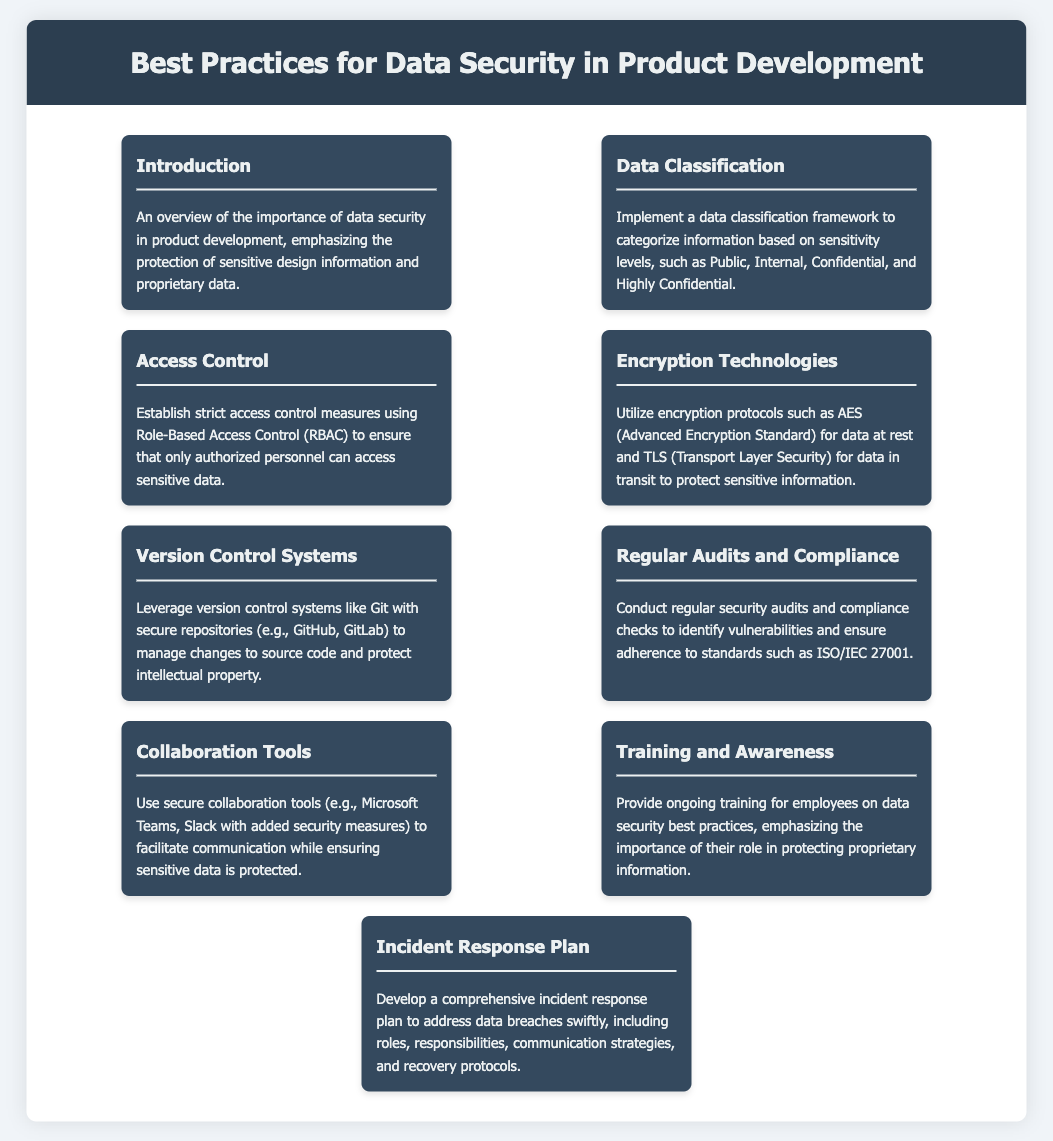What is the title of the document? The title of the document is presented in the header of the rendered document.
Answer: Best Practices for Data Security in Product Development What section outlines the importance of data security? The importance of data security is addressed in the "Introduction" section of the document.
Answer: Introduction What encryption protocol is recommended for data at rest? The document specifies the recommended encryption protocol for data at rest.
Answer: AES How often should security audits be conducted? The document states the need for regular security audits and compliance checks.
Answer: Regularly What access control method is suggested in the document? The document advises using Role-Based Access Control (RBAC) for access control.
Answer: RBAC What is the purpose of the Incident Response Plan? The document mentions the Incident Response Plan's purpose in addressing data breaches.
Answer: Address data breaches What security feature should collaboration tools include? The document suggests that collaboration tools should have added security measures.
Answer: Added security measures Which system is recommended for managing changes to source code? The document recommends using version control systems like Git.
Answer: Git What training is emphasized for employees? The document emphasizes the need to provide ongoing training for employees on data security practices.
Answer: Ongoing training 